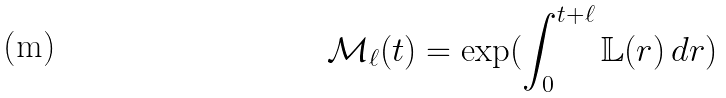Convert formula to latex. <formula><loc_0><loc_0><loc_500><loc_500>\mathcal { M } _ { \ell } ( t ) = \exp ( \int _ { 0 } ^ { t + \ell } \mathbb { L } ( r ) \, d r )</formula> 